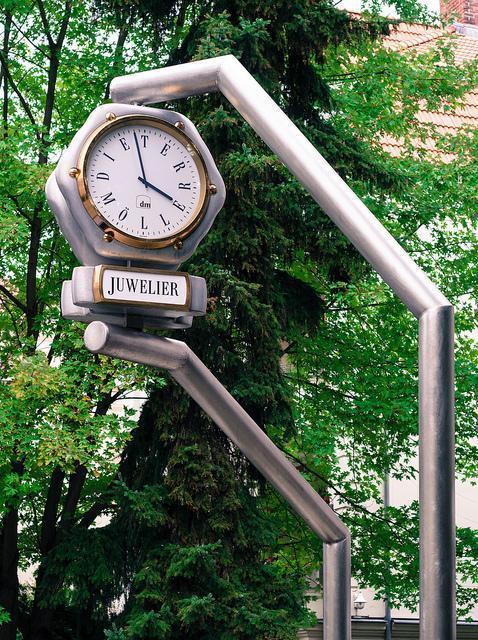How many rolls of toilet paper is there?
Give a very brief answer. 0. 